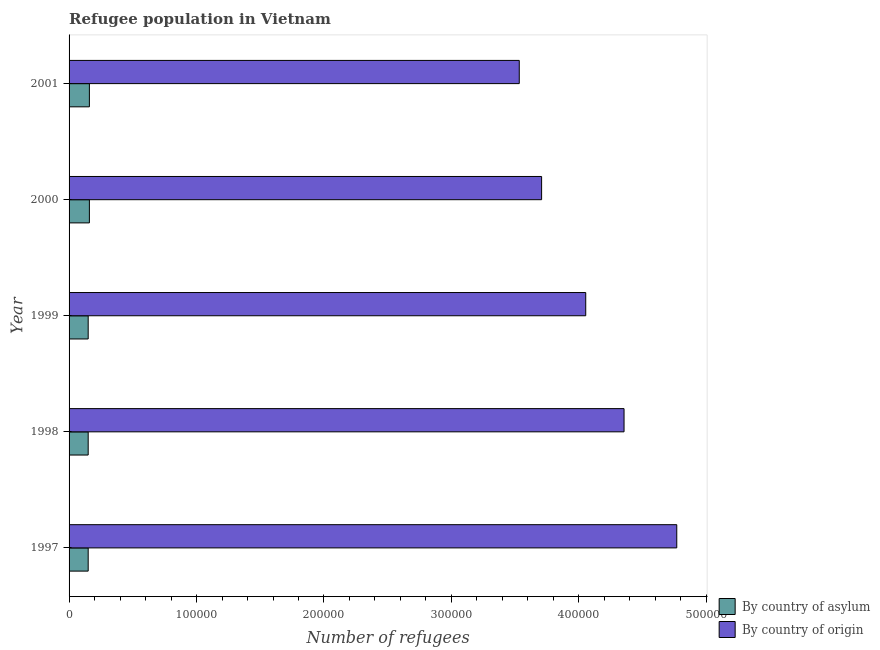Are the number of bars on each tick of the Y-axis equal?
Keep it short and to the point. Yes. How many bars are there on the 3rd tick from the top?
Ensure brevity in your answer.  2. How many bars are there on the 5th tick from the bottom?
Provide a succinct answer. 2. In how many cases, is the number of bars for a given year not equal to the number of legend labels?
Provide a succinct answer. 0. What is the number of refugees by country of origin in 1998?
Your answer should be compact. 4.35e+05. Across all years, what is the maximum number of refugees by country of origin?
Ensure brevity in your answer.  4.77e+05. Across all years, what is the minimum number of refugees by country of origin?
Ensure brevity in your answer.  3.53e+05. In which year was the number of refugees by country of origin minimum?
Ensure brevity in your answer.  2001. What is the total number of refugees by country of asylum in the graph?
Your response must be concise. 7.69e+04. What is the difference between the number of refugees by country of origin in 1998 and that in 2001?
Your response must be concise. 8.22e+04. What is the difference between the number of refugees by country of asylum in 1998 and the number of refugees by country of origin in 2001?
Ensure brevity in your answer.  -3.38e+05. What is the average number of refugees by country of origin per year?
Offer a terse response. 4.08e+05. In the year 1997, what is the difference between the number of refugees by country of asylum and number of refugees by country of origin?
Your answer should be very brief. -4.62e+05. In how many years, is the number of refugees by country of asylum greater than 480000 ?
Keep it short and to the point. 0. Is the number of refugees by country of origin in 1997 less than that in 2000?
Give a very brief answer. No. What is the difference between the highest and the second highest number of refugees by country of origin?
Offer a very short reply. 4.14e+04. What is the difference between the highest and the lowest number of refugees by country of origin?
Provide a short and direct response. 1.24e+05. What does the 1st bar from the top in 1999 represents?
Make the answer very short. By country of origin. What does the 1st bar from the bottom in 2000 represents?
Offer a very short reply. By country of asylum. How many years are there in the graph?
Give a very brief answer. 5. Does the graph contain grids?
Keep it short and to the point. No. Where does the legend appear in the graph?
Your answer should be compact. Bottom right. How are the legend labels stacked?
Make the answer very short. Vertical. What is the title of the graph?
Provide a short and direct response. Refugee population in Vietnam. Does "National Tourists" appear as one of the legend labels in the graph?
Offer a terse response. No. What is the label or title of the X-axis?
Your response must be concise. Number of refugees. What is the label or title of the Y-axis?
Offer a very short reply. Year. What is the Number of refugees in By country of asylum in 1997?
Keep it short and to the point. 1.50e+04. What is the Number of refugees in By country of origin in 1997?
Offer a terse response. 4.77e+05. What is the Number of refugees of By country of asylum in 1998?
Keep it short and to the point. 1.50e+04. What is the Number of refugees of By country of origin in 1998?
Provide a succinct answer. 4.35e+05. What is the Number of refugees of By country of asylum in 1999?
Provide a succinct answer. 1.50e+04. What is the Number of refugees of By country of origin in 1999?
Make the answer very short. 4.05e+05. What is the Number of refugees in By country of asylum in 2000?
Provide a short and direct response. 1.59e+04. What is the Number of refugees in By country of origin in 2000?
Offer a very short reply. 3.71e+05. What is the Number of refugees of By country of asylum in 2001?
Offer a terse response. 1.59e+04. What is the Number of refugees in By country of origin in 2001?
Provide a short and direct response. 3.53e+05. Across all years, what is the maximum Number of refugees of By country of asylum?
Ensure brevity in your answer.  1.59e+04. Across all years, what is the maximum Number of refugees in By country of origin?
Offer a terse response. 4.77e+05. Across all years, what is the minimum Number of refugees of By country of asylum?
Keep it short and to the point. 1.50e+04. Across all years, what is the minimum Number of refugees in By country of origin?
Your answer should be compact. 3.53e+05. What is the total Number of refugees in By country of asylum in the graph?
Your answer should be very brief. 7.69e+04. What is the total Number of refugees in By country of origin in the graph?
Offer a very short reply. 2.04e+06. What is the difference between the Number of refugees in By country of origin in 1997 and that in 1998?
Offer a terse response. 4.14e+04. What is the difference between the Number of refugees in By country of asylum in 1997 and that in 1999?
Keep it short and to the point. 0. What is the difference between the Number of refugees in By country of origin in 1997 and that in 1999?
Your answer should be very brief. 7.14e+04. What is the difference between the Number of refugees of By country of asylum in 1997 and that in 2000?
Offer a very short reply. -945. What is the difference between the Number of refugees in By country of origin in 1997 and that in 2000?
Make the answer very short. 1.06e+05. What is the difference between the Number of refugees in By country of asylum in 1997 and that in 2001?
Keep it short and to the point. -945. What is the difference between the Number of refugees in By country of origin in 1997 and that in 2001?
Provide a short and direct response. 1.24e+05. What is the difference between the Number of refugees in By country of origin in 1998 and that in 1999?
Your answer should be compact. 3.01e+04. What is the difference between the Number of refugees in By country of asylum in 1998 and that in 2000?
Provide a succinct answer. -945. What is the difference between the Number of refugees in By country of origin in 1998 and that in 2000?
Ensure brevity in your answer.  6.47e+04. What is the difference between the Number of refugees of By country of asylum in 1998 and that in 2001?
Your answer should be very brief. -945. What is the difference between the Number of refugees of By country of origin in 1998 and that in 2001?
Your answer should be compact. 8.22e+04. What is the difference between the Number of refugees of By country of asylum in 1999 and that in 2000?
Offer a terse response. -945. What is the difference between the Number of refugees of By country of origin in 1999 and that in 2000?
Provide a short and direct response. 3.46e+04. What is the difference between the Number of refugees of By country of asylum in 1999 and that in 2001?
Make the answer very short. -945. What is the difference between the Number of refugees of By country of origin in 1999 and that in 2001?
Provide a succinct answer. 5.22e+04. What is the difference between the Number of refugees of By country of asylum in 2000 and that in 2001?
Keep it short and to the point. 0. What is the difference between the Number of refugees of By country of origin in 2000 and that in 2001?
Keep it short and to the point. 1.75e+04. What is the difference between the Number of refugees of By country of asylum in 1997 and the Number of refugees of By country of origin in 1998?
Your answer should be compact. -4.20e+05. What is the difference between the Number of refugees in By country of asylum in 1997 and the Number of refugees in By country of origin in 1999?
Ensure brevity in your answer.  -3.90e+05. What is the difference between the Number of refugees in By country of asylum in 1997 and the Number of refugees in By country of origin in 2000?
Give a very brief answer. -3.56e+05. What is the difference between the Number of refugees of By country of asylum in 1997 and the Number of refugees of By country of origin in 2001?
Provide a short and direct response. -3.38e+05. What is the difference between the Number of refugees in By country of asylum in 1998 and the Number of refugees in By country of origin in 1999?
Offer a very short reply. -3.90e+05. What is the difference between the Number of refugees in By country of asylum in 1998 and the Number of refugees in By country of origin in 2000?
Ensure brevity in your answer.  -3.56e+05. What is the difference between the Number of refugees of By country of asylum in 1998 and the Number of refugees of By country of origin in 2001?
Offer a terse response. -3.38e+05. What is the difference between the Number of refugees of By country of asylum in 1999 and the Number of refugees of By country of origin in 2000?
Provide a short and direct response. -3.56e+05. What is the difference between the Number of refugees of By country of asylum in 1999 and the Number of refugees of By country of origin in 2001?
Your answer should be compact. -3.38e+05. What is the difference between the Number of refugees in By country of asylum in 2000 and the Number of refugees in By country of origin in 2001?
Make the answer very short. -3.37e+05. What is the average Number of refugees of By country of asylum per year?
Your response must be concise. 1.54e+04. What is the average Number of refugees of By country of origin per year?
Your response must be concise. 4.08e+05. In the year 1997, what is the difference between the Number of refugees in By country of asylum and Number of refugees in By country of origin?
Your answer should be compact. -4.62e+05. In the year 1998, what is the difference between the Number of refugees in By country of asylum and Number of refugees in By country of origin?
Provide a succinct answer. -4.20e+05. In the year 1999, what is the difference between the Number of refugees of By country of asylum and Number of refugees of By country of origin?
Provide a short and direct response. -3.90e+05. In the year 2000, what is the difference between the Number of refugees in By country of asylum and Number of refugees in By country of origin?
Ensure brevity in your answer.  -3.55e+05. In the year 2001, what is the difference between the Number of refugees in By country of asylum and Number of refugees in By country of origin?
Make the answer very short. -3.37e+05. What is the ratio of the Number of refugees in By country of origin in 1997 to that in 1998?
Offer a very short reply. 1.09. What is the ratio of the Number of refugees of By country of origin in 1997 to that in 1999?
Ensure brevity in your answer.  1.18. What is the ratio of the Number of refugees in By country of asylum in 1997 to that in 2000?
Make the answer very short. 0.94. What is the ratio of the Number of refugees in By country of origin in 1997 to that in 2000?
Your response must be concise. 1.29. What is the ratio of the Number of refugees of By country of asylum in 1997 to that in 2001?
Make the answer very short. 0.94. What is the ratio of the Number of refugees in By country of origin in 1997 to that in 2001?
Provide a succinct answer. 1.35. What is the ratio of the Number of refugees of By country of origin in 1998 to that in 1999?
Make the answer very short. 1.07. What is the ratio of the Number of refugees in By country of asylum in 1998 to that in 2000?
Keep it short and to the point. 0.94. What is the ratio of the Number of refugees in By country of origin in 1998 to that in 2000?
Ensure brevity in your answer.  1.17. What is the ratio of the Number of refugees in By country of asylum in 1998 to that in 2001?
Your answer should be very brief. 0.94. What is the ratio of the Number of refugees of By country of origin in 1998 to that in 2001?
Your response must be concise. 1.23. What is the ratio of the Number of refugees of By country of asylum in 1999 to that in 2000?
Offer a very short reply. 0.94. What is the ratio of the Number of refugees in By country of origin in 1999 to that in 2000?
Offer a very short reply. 1.09. What is the ratio of the Number of refugees of By country of asylum in 1999 to that in 2001?
Ensure brevity in your answer.  0.94. What is the ratio of the Number of refugees of By country of origin in 1999 to that in 2001?
Your answer should be compact. 1.15. What is the ratio of the Number of refugees in By country of asylum in 2000 to that in 2001?
Your answer should be compact. 1. What is the ratio of the Number of refugees in By country of origin in 2000 to that in 2001?
Offer a very short reply. 1.05. What is the difference between the highest and the second highest Number of refugees of By country of origin?
Offer a terse response. 4.14e+04. What is the difference between the highest and the lowest Number of refugees of By country of asylum?
Offer a terse response. 945. What is the difference between the highest and the lowest Number of refugees in By country of origin?
Provide a succinct answer. 1.24e+05. 